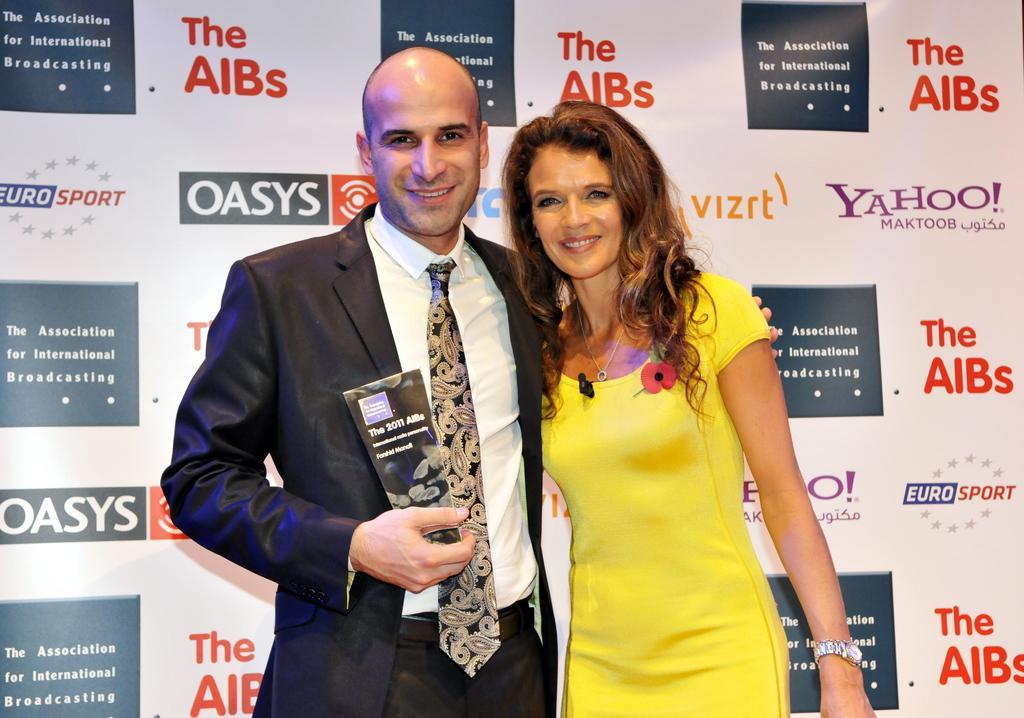How would you summarize this image in a sentence or two? In the foreground of this image, there are two persons. One woman in yellow colored dress and man in blue suit. They both are having smile on their faces. In the background, there is a banner. 